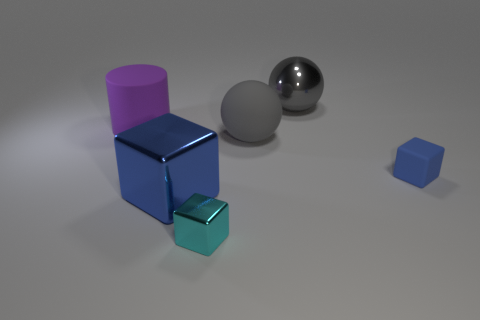What could be the function of these objects in a real-world setting? These objects seem to serve an illustrative purpose, such as prototyping shapes for educational purposes or in computer graphics to demonstrate lighting and shading techniques. Since they resemble geometric solids, they could also be part of a set to teach mathematical concepts or perhaps components used in spatial reasoning puzzles. 